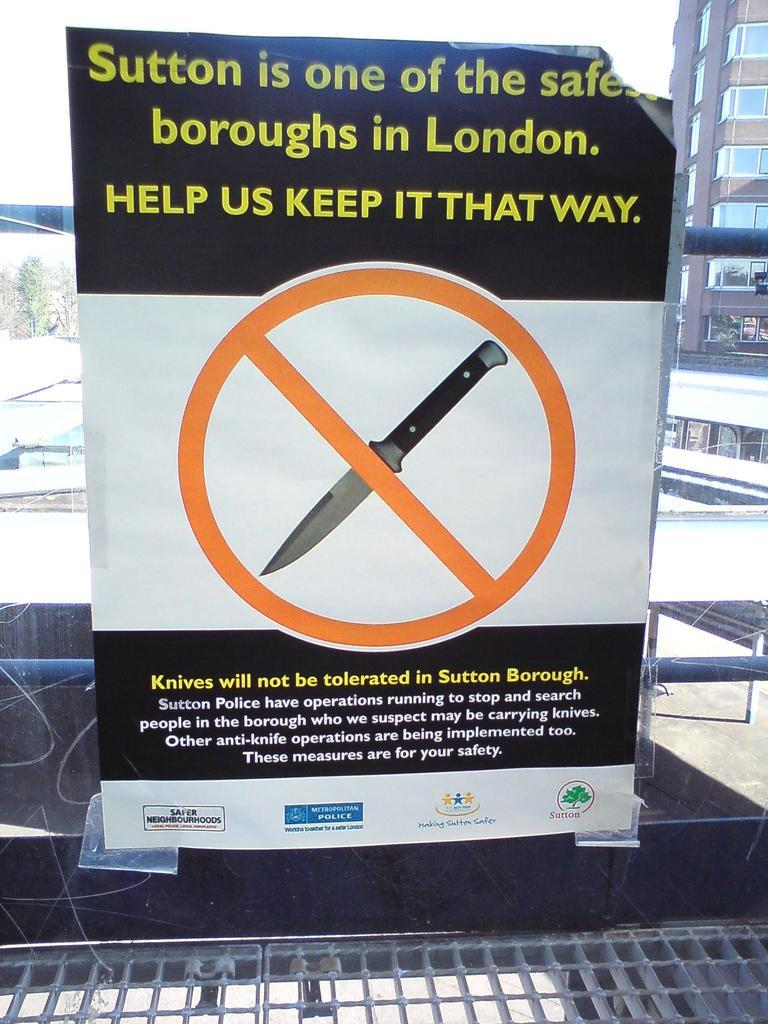Provide a one-sentence caption for the provided image. If visiting Sutton Burough this sign states that one should not bring a knife. 